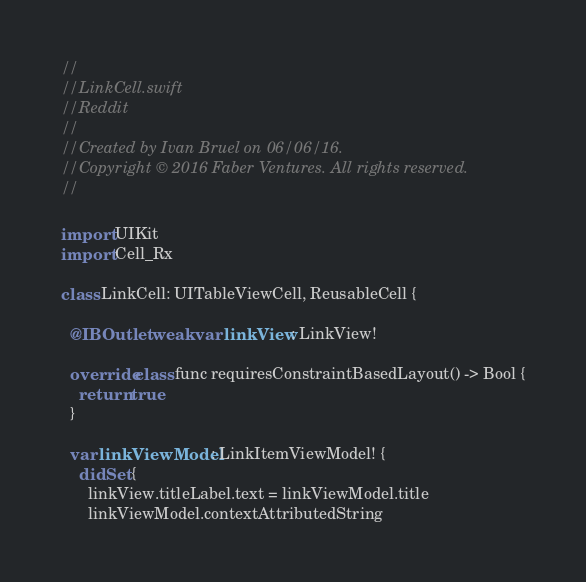<code> <loc_0><loc_0><loc_500><loc_500><_Swift_>//
//  LinkCell.swift
//  Reddit
//
//  Created by Ivan Bruel on 06/06/16.
//  Copyright © 2016 Faber Ventures. All rights reserved.
//

import UIKit
import Cell_Rx

class LinkCell: UITableViewCell, ReusableCell {

  @IBOutlet weak var linkView: LinkView!

  override class func requiresConstraintBasedLayout() -> Bool {
    return true
  }

  var linkViewModel: LinkItemViewModel! {
    didSet {
      linkView.titleLabel.text = linkViewModel.title
      linkViewModel.contextAttributedString</code> 